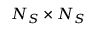<formula> <loc_0><loc_0><loc_500><loc_500>N _ { S } \times N _ { S }</formula> 